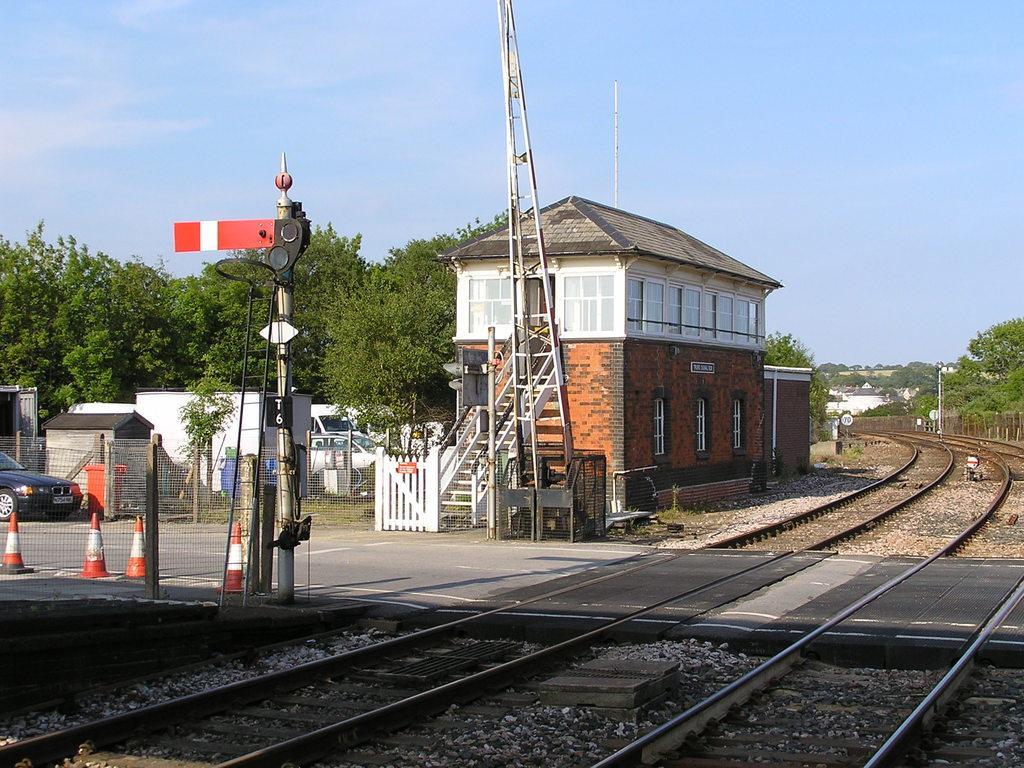Could you give a brief overview of what you see in this image? In this image I can see a house in brown and white color. I can also see few poles in orange color, a vehicle. Background I can see trees in green color and sky in blue and white color. 